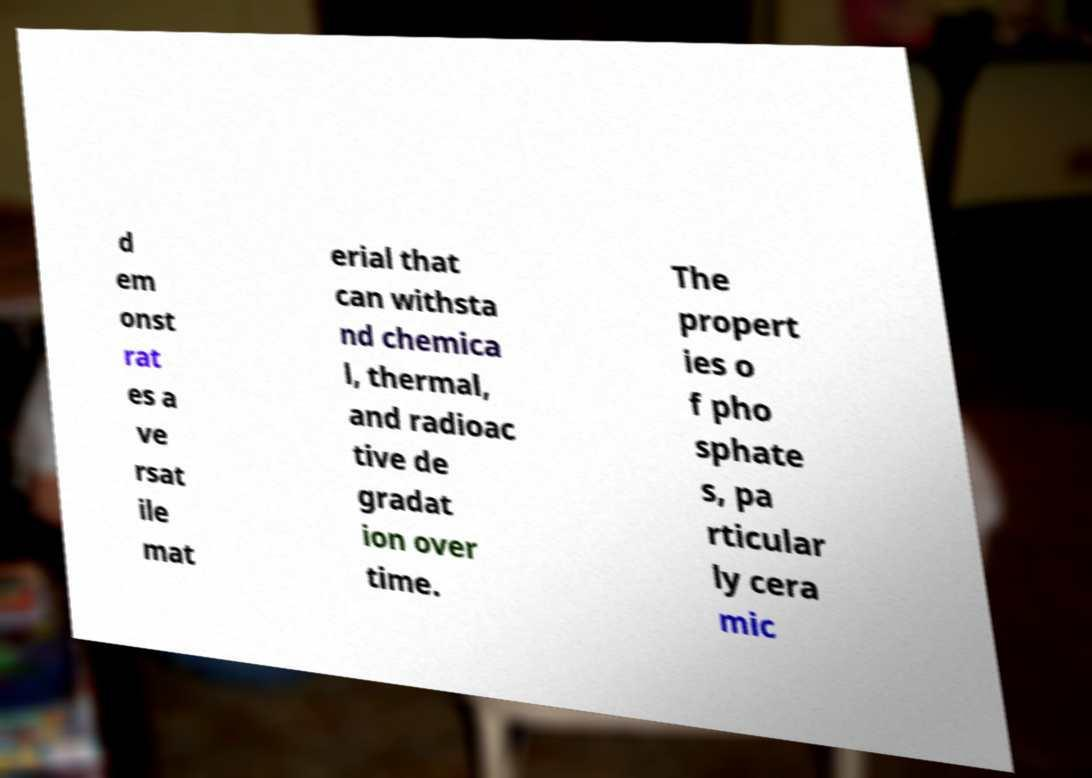Could you extract and type out the text from this image? d em onst rat es a ve rsat ile mat erial that can withsta nd chemica l, thermal, and radioac tive de gradat ion over time. The propert ies o f pho sphate s, pa rticular ly cera mic 